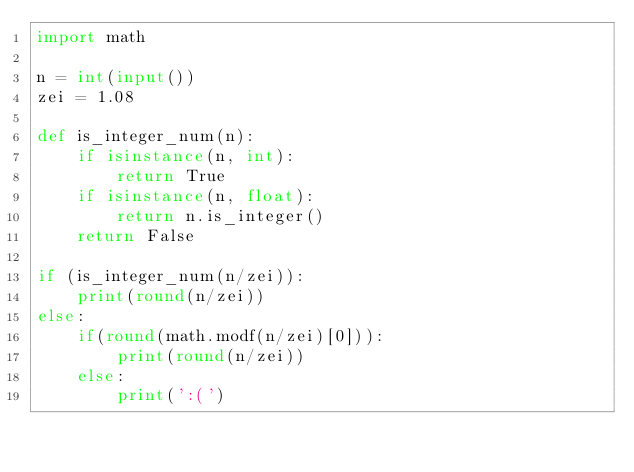Convert code to text. <code><loc_0><loc_0><loc_500><loc_500><_Python_>import math

n = int(input())
zei = 1.08

def is_integer_num(n):
    if isinstance(n, int):
        return True
    if isinstance(n, float):
        return n.is_integer()
    return False

if (is_integer_num(n/zei)):
    print(round(n/zei))
else:
    if(round(math.modf(n/zei)[0])):
        print(round(n/zei))
    else:
        print(':(')
</code> 